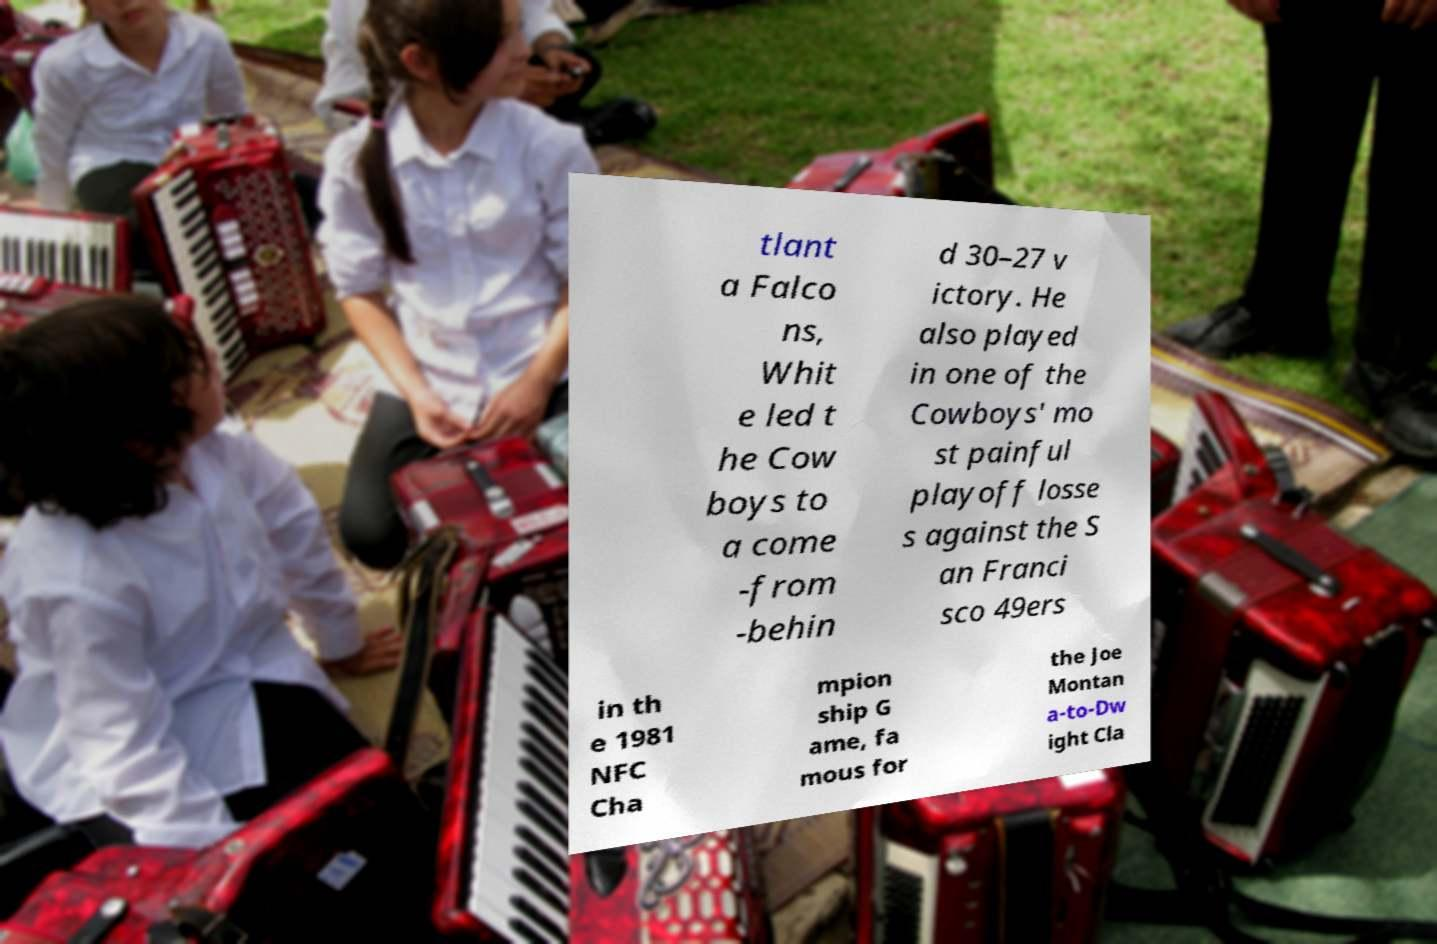There's text embedded in this image that I need extracted. Can you transcribe it verbatim? tlant a Falco ns, Whit e led t he Cow boys to a come -from -behin d 30–27 v ictory. He also played in one of the Cowboys' mo st painful playoff losse s against the S an Franci sco 49ers in th e 1981 NFC Cha mpion ship G ame, fa mous for the Joe Montan a-to-Dw ight Cla 